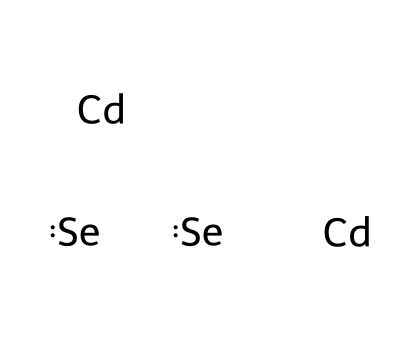What elements are present in cadmium selenide quantum dots? The SMILES representation shows "Cd" for cadmium and "Se" for selenium, indicating that the elements present are cadmium and selenium.
Answer: cadmium and selenium How many cadmium atoms are there in the structure? The SMILES representation includes two occurrences of "Cd," which means there are two cadmium atoms in the structure.
Answer: two What is the total number of atoms in cadmium selenide quantum dots? The structure contains two cadmium atoms and two selenium atoms, making the total number of atoms four.
Answer: four Which type of structure is represented by the combination of cadmium and selenium? The combination of cadmium and selenium typically forms a semiconductor material known as a quantum dot, specifically cadmium selenide quantum dots in this case.
Answer: cadmium selenide quantum dots What type of bonding is likely present between cadmium and selenium atoms? Cadmium and selenium are expected to form ionic bonding due to the transfer of electrons from cadmium (a metal) to selenium (a non-metal), characteristic of semiconductor compounds.
Answer: ionic bonding What property does the quantum dot size affect? The size of quantum dots, such as cadmium selenide, significantly affects their optical properties, particularly the wavelength of emitted light, leading to variations in color.
Answer: optical properties 